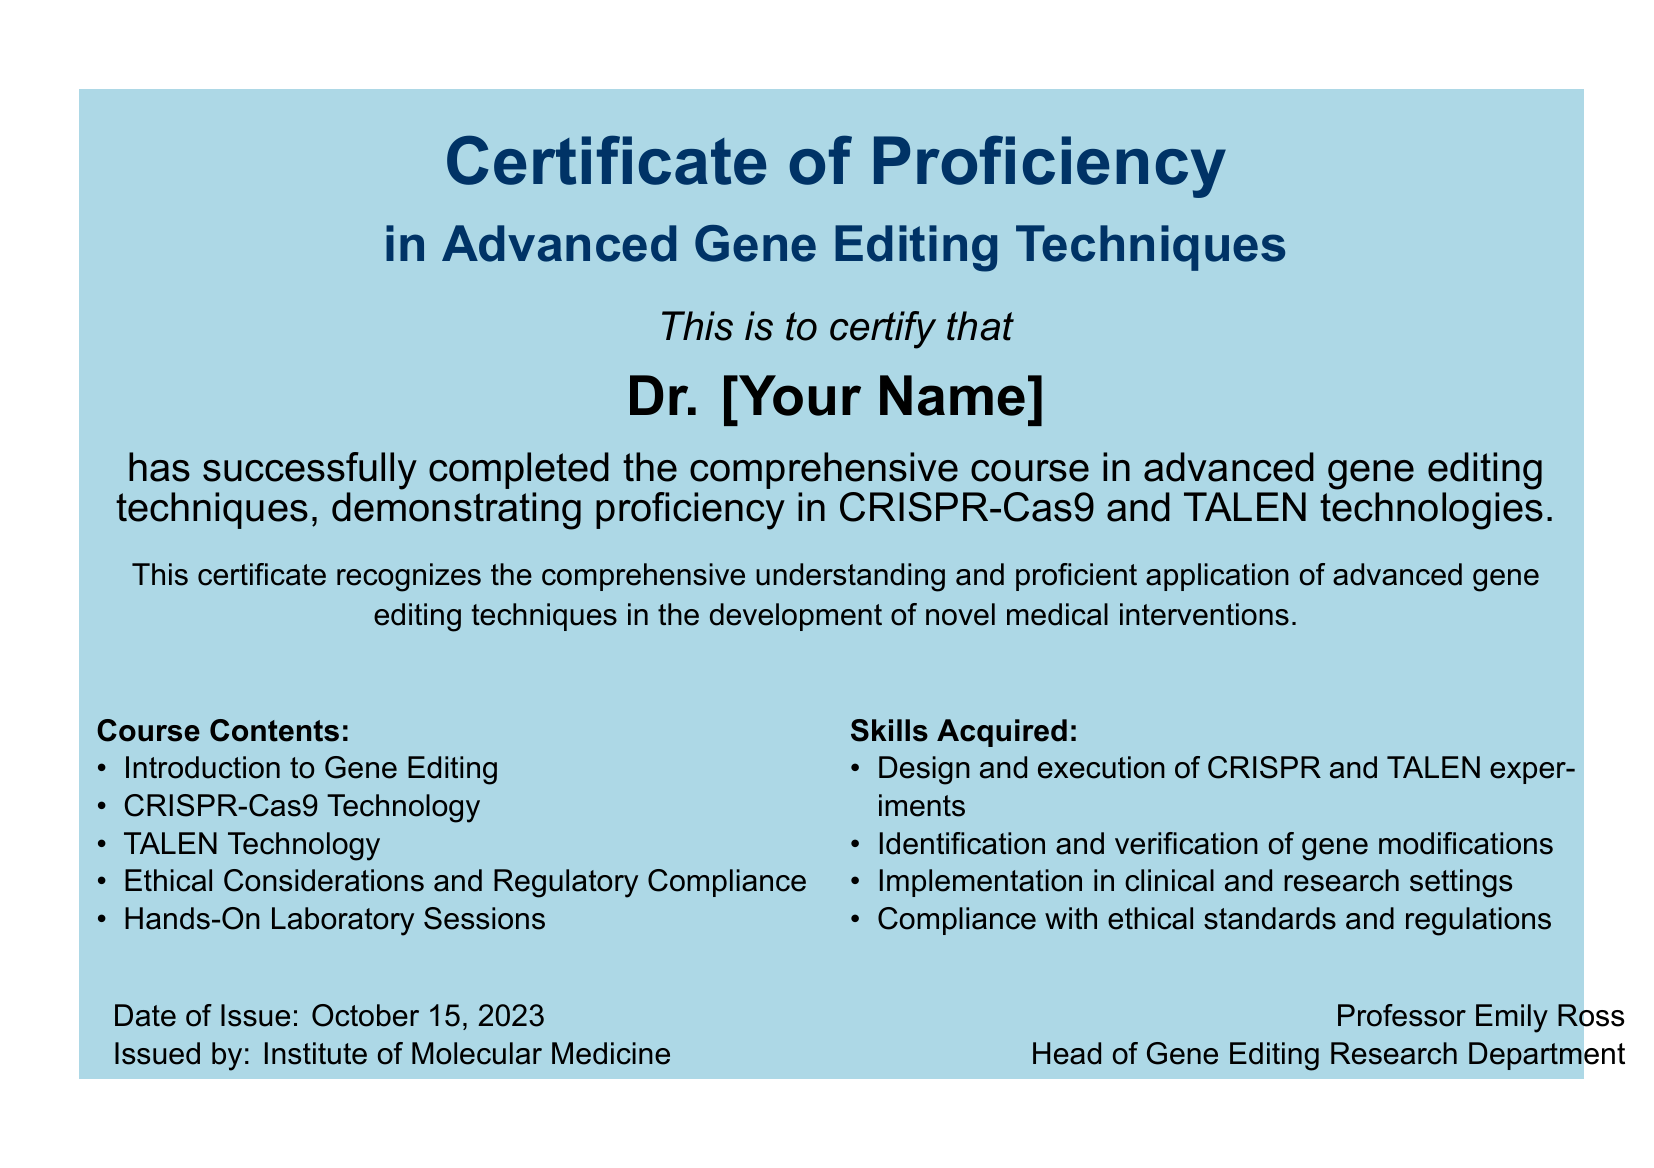What is the title of the certificate? The title of the certificate is prominently displayed at the top of the document, stating the purpose and focus of the certificate.
Answer: Certificate of Proficiency in Advanced Gene Editing Techniques Who is the certificate issued to? The name of the individual receiving the certificate is highlighted in a larger font in the center of the document.
Answer: Dr. [Your Name] When was the certificate issued? The date when the certificate was issued is listed at the bottom left of the document.
Answer: October 15, 2023 Who issued the certificate? The issuing body is identified in the same location as the date, indicating the organization responsible for the certification.
Answer: Institute of Molecular Medicine What technologies are covered in the course? The course contents include specific technologies that are a fundamental part of the certificate’s focus.
Answer: CRISPR-Cas9 and TALEN technologies What skills are acquired from this course? The skills obtained from the course can be found in the section detailing what participants learn, highlighting practical applications.
Answer: Design and execution of CRISPR and TALEN experiments What ethical considerations are included in the course? The document lists ethical considerations as part of the course contents, indicating the importance of compliance in gene editing practices.
Answer: Ethical Considerations and Regulatory Compliance Who is the head of the Gene Editing Research Department? The document includes a signature and title of the individual who has a leadership role at the issuing institute, providing credibility.
Answer: Professor Emily Ross 